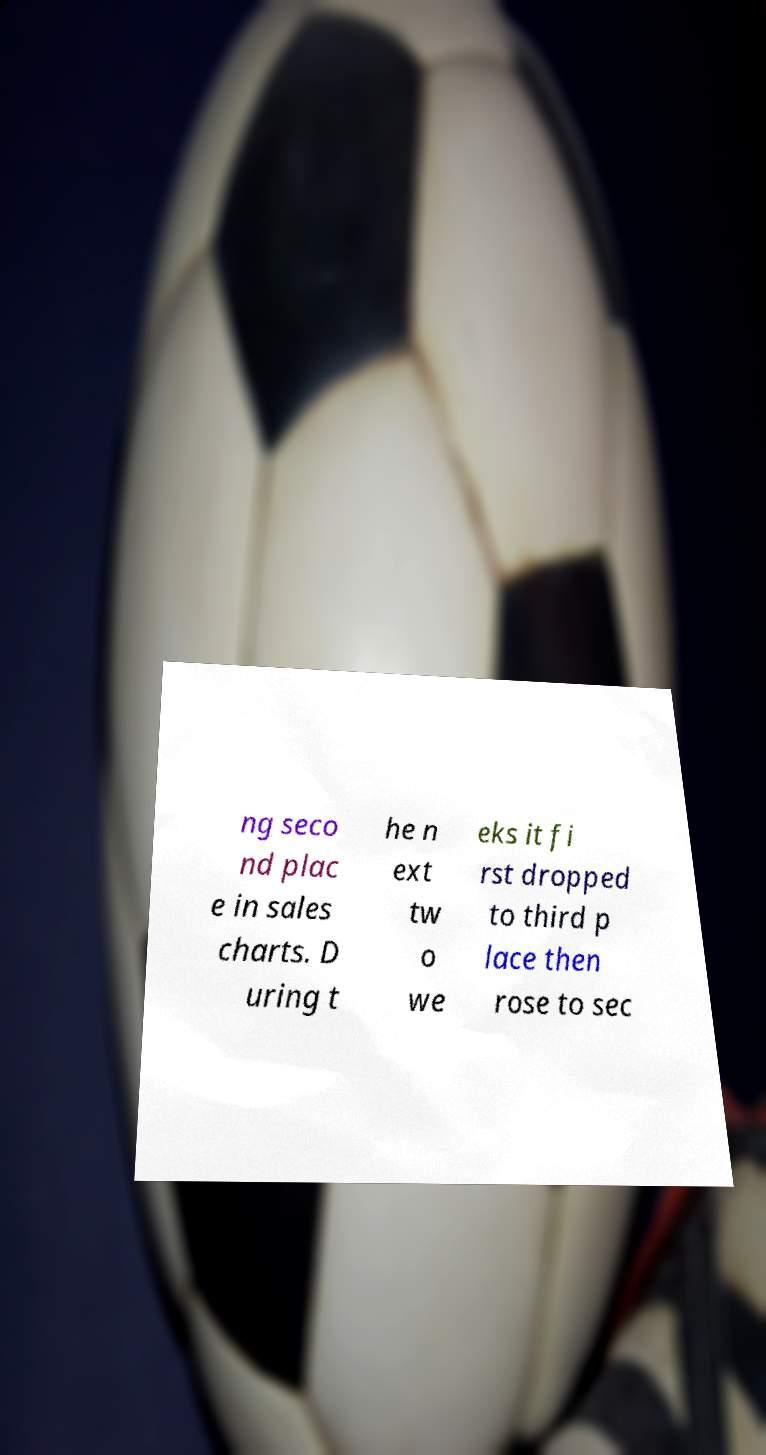There's text embedded in this image that I need extracted. Can you transcribe it verbatim? ng seco nd plac e in sales charts. D uring t he n ext tw o we eks it fi rst dropped to third p lace then rose to sec 